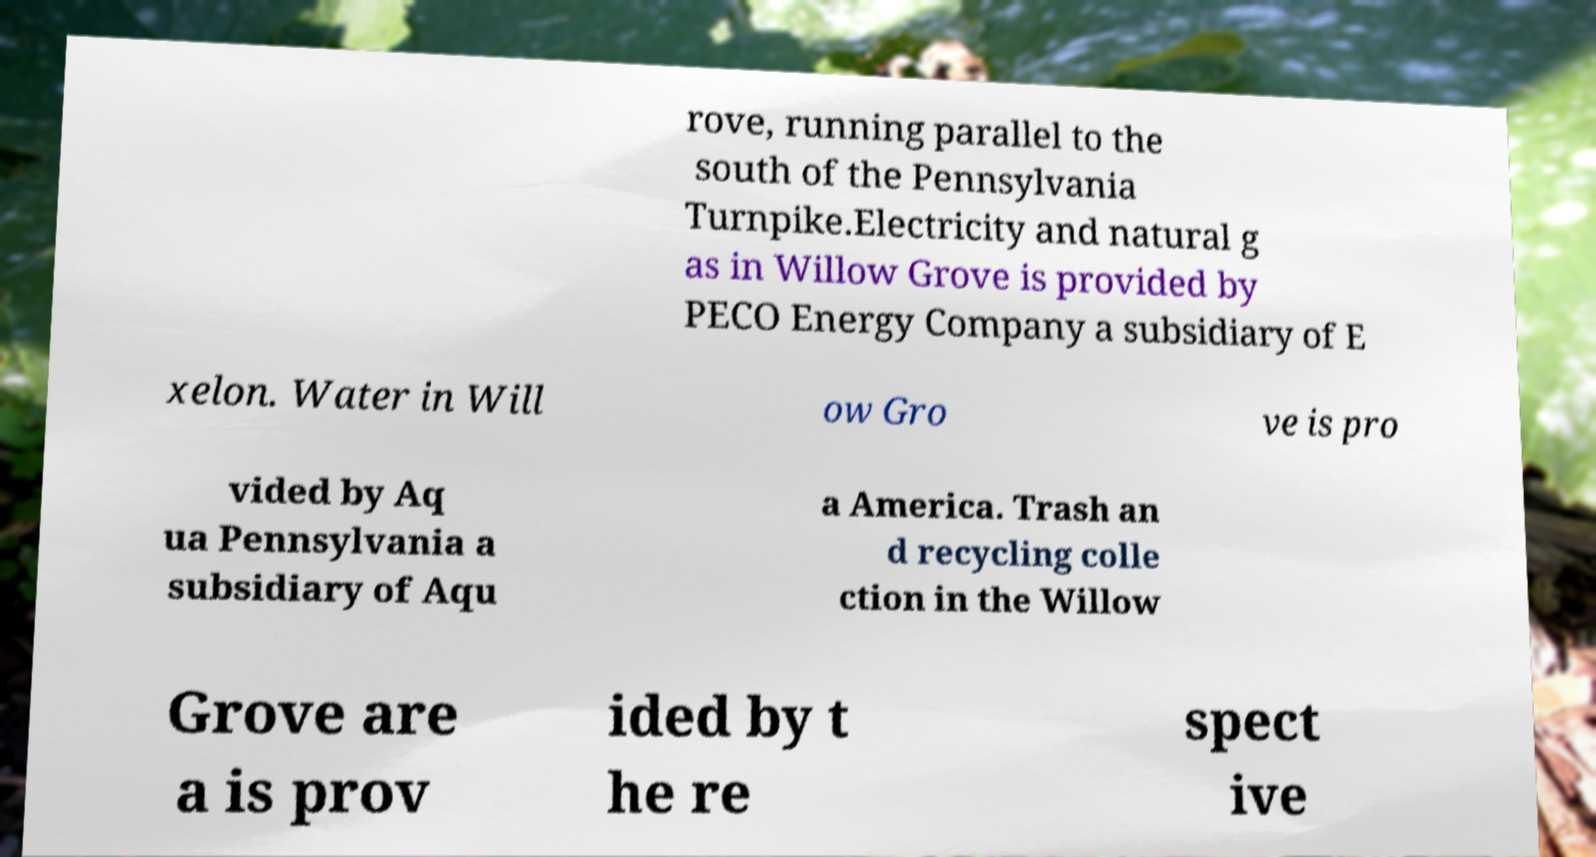Could you extract and type out the text from this image? rove, running parallel to the south of the Pennsylvania Turnpike.Electricity and natural g as in Willow Grove is provided by PECO Energy Company a subsidiary of E xelon. Water in Will ow Gro ve is pro vided by Aq ua Pennsylvania a subsidiary of Aqu a America. Trash an d recycling colle ction in the Willow Grove are a is prov ided by t he re spect ive 